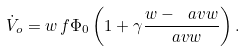<formula> <loc_0><loc_0><loc_500><loc_500>\dot { V } _ { o } = w \, f \Phi _ { 0 } \left ( 1 + \gamma \frac { w - \ a v { w } } { \ a v { w } } \right ) .</formula> 